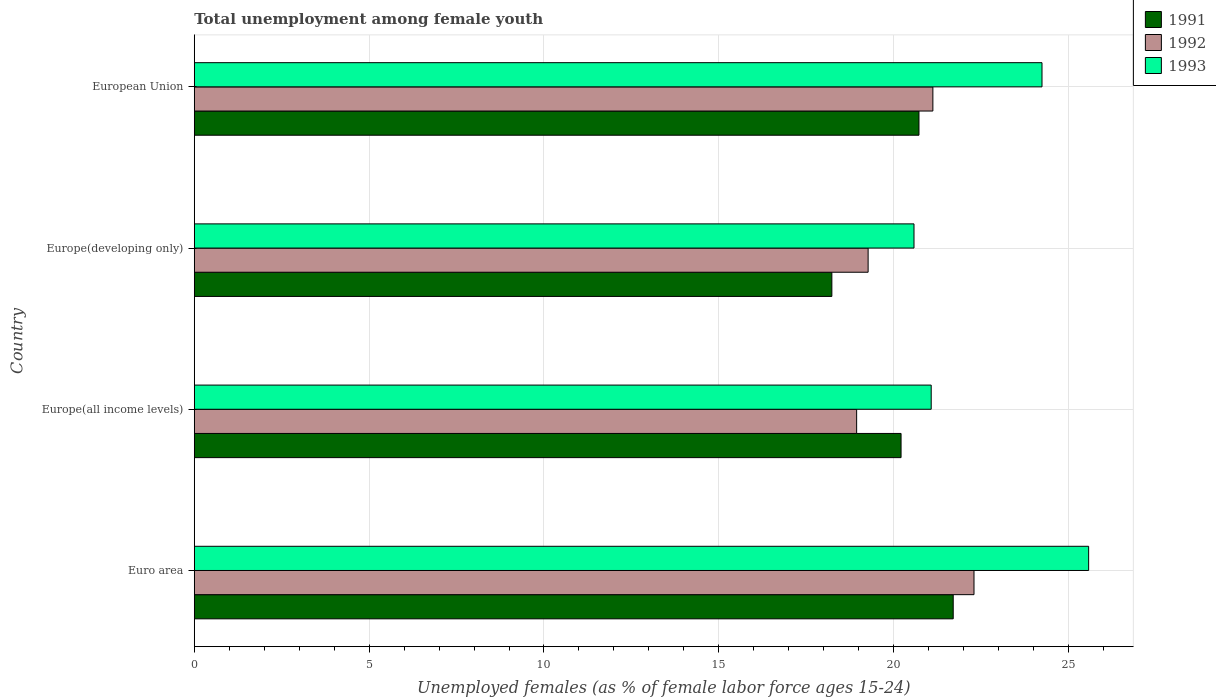How many different coloured bars are there?
Provide a short and direct response. 3. How many groups of bars are there?
Give a very brief answer. 4. How many bars are there on the 3rd tick from the top?
Ensure brevity in your answer.  3. How many bars are there on the 3rd tick from the bottom?
Give a very brief answer. 3. What is the label of the 3rd group of bars from the top?
Provide a succinct answer. Europe(all income levels). What is the percentage of unemployed females in in 1993 in Europe(all income levels)?
Ensure brevity in your answer.  21.07. Across all countries, what is the maximum percentage of unemployed females in in 1993?
Ensure brevity in your answer.  25.57. Across all countries, what is the minimum percentage of unemployed females in in 1993?
Your answer should be very brief. 20.58. In which country was the percentage of unemployed females in in 1991 minimum?
Make the answer very short. Europe(developing only). What is the total percentage of unemployed females in in 1993 in the graph?
Give a very brief answer. 91.47. What is the difference between the percentage of unemployed females in in 1991 in Europe(all income levels) and that in Europe(developing only)?
Provide a succinct answer. 1.98. What is the difference between the percentage of unemployed females in in 1991 in Europe(all income levels) and the percentage of unemployed females in in 1992 in Europe(developing only)?
Ensure brevity in your answer.  0.94. What is the average percentage of unemployed females in in 1993 per country?
Offer a very short reply. 22.87. What is the difference between the percentage of unemployed females in in 1993 and percentage of unemployed females in in 1992 in European Union?
Keep it short and to the point. 3.12. In how many countries, is the percentage of unemployed females in in 1992 greater than 4 %?
Make the answer very short. 4. What is the ratio of the percentage of unemployed females in in 1992 in Euro area to that in European Union?
Offer a terse response. 1.06. Is the percentage of unemployed females in in 1992 in Europe(all income levels) less than that in Europe(developing only)?
Offer a very short reply. Yes. Is the difference between the percentage of unemployed females in in 1993 in Euro area and Europe(developing only) greater than the difference between the percentage of unemployed females in in 1992 in Euro area and Europe(developing only)?
Give a very brief answer. Yes. What is the difference between the highest and the second highest percentage of unemployed females in in 1991?
Provide a short and direct response. 0.98. What is the difference between the highest and the lowest percentage of unemployed females in in 1991?
Your response must be concise. 3.47. Is the sum of the percentage of unemployed females in in 1992 in Europe(all income levels) and Europe(developing only) greater than the maximum percentage of unemployed females in in 1993 across all countries?
Make the answer very short. Yes. Is it the case that in every country, the sum of the percentage of unemployed females in in 1993 and percentage of unemployed females in in 1992 is greater than the percentage of unemployed females in in 1991?
Keep it short and to the point. Yes. What is the difference between two consecutive major ticks on the X-axis?
Keep it short and to the point. 5. Are the values on the major ticks of X-axis written in scientific E-notation?
Your answer should be very brief. No. Does the graph contain any zero values?
Make the answer very short. No. Does the graph contain grids?
Give a very brief answer. Yes. Where does the legend appear in the graph?
Your answer should be very brief. Top right. What is the title of the graph?
Ensure brevity in your answer.  Total unemployment among female youth. What is the label or title of the X-axis?
Offer a very short reply. Unemployed females (as % of female labor force ages 15-24). What is the label or title of the Y-axis?
Your response must be concise. Country. What is the Unemployed females (as % of female labor force ages 15-24) in 1991 in Euro area?
Give a very brief answer. 21.7. What is the Unemployed females (as % of female labor force ages 15-24) in 1992 in Euro area?
Your answer should be compact. 22.3. What is the Unemployed females (as % of female labor force ages 15-24) of 1993 in Euro area?
Your response must be concise. 25.57. What is the Unemployed females (as % of female labor force ages 15-24) in 1991 in Europe(all income levels)?
Offer a terse response. 20.21. What is the Unemployed females (as % of female labor force ages 15-24) in 1992 in Europe(all income levels)?
Provide a short and direct response. 18.94. What is the Unemployed females (as % of female labor force ages 15-24) in 1993 in Europe(all income levels)?
Give a very brief answer. 21.07. What is the Unemployed females (as % of female labor force ages 15-24) in 1991 in Europe(developing only)?
Give a very brief answer. 18.23. What is the Unemployed females (as % of female labor force ages 15-24) of 1992 in Europe(developing only)?
Your response must be concise. 19.27. What is the Unemployed females (as % of female labor force ages 15-24) of 1993 in Europe(developing only)?
Provide a short and direct response. 20.58. What is the Unemployed females (as % of female labor force ages 15-24) of 1991 in European Union?
Provide a succinct answer. 20.72. What is the Unemployed females (as % of female labor force ages 15-24) in 1992 in European Union?
Provide a succinct answer. 21.12. What is the Unemployed females (as % of female labor force ages 15-24) of 1993 in European Union?
Your answer should be very brief. 24.24. Across all countries, what is the maximum Unemployed females (as % of female labor force ages 15-24) in 1991?
Give a very brief answer. 21.7. Across all countries, what is the maximum Unemployed females (as % of female labor force ages 15-24) of 1992?
Keep it short and to the point. 22.3. Across all countries, what is the maximum Unemployed females (as % of female labor force ages 15-24) in 1993?
Provide a succinct answer. 25.57. Across all countries, what is the minimum Unemployed females (as % of female labor force ages 15-24) in 1991?
Make the answer very short. 18.23. Across all countries, what is the minimum Unemployed females (as % of female labor force ages 15-24) in 1992?
Your answer should be compact. 18.94. Across all countries, what is the minimum Unemployed females (as % of female labor force ages 15-24) of 1993?
Offer a terse response. 20.58. What is the total Unemployed females (as % of female labor force ages 15-24) of 1991 in the graph?
Offer a very short reply. 80.87. What is the total Unemployed females (as % of female labor force ages 15-24) in 1992 in the graph?
Give a very brief answer. 81.63. What is the total Unemployed females (as % of female labor force ages 15-24) in 1993 in the graph?
Offer a terse response. 91.47. What is the difference between the Unemployed females (as % of female labor force ages 15-24) in 1991 in Euro area and that in Europe(all income levels)?
Your answer should be compact. 1.49. What is the difference between the Unemployed females (as % of female labor force ages 15-24) of 1992 in Euro area and that in Europe(all income levels)?
Your response must be concise. 3.36. What is the difference between the Unemployed females (as % of female labor force ages 15-24) of 1993 in Euro area and that in Europe(all income levels)?
Offer a very short reply. 4.5. What is the difference between the Unemployed females (as % of female labor force ages 15-24) in 1991 in Euro area and that in Europe(developing only)?
Your answer should be very brief. 3.47. What is the difference between the Unemployed females (as % of female labor force ages 15-24) of 1992 in Euro area and that in Europe(developing only)?
Offer a terse response. 3.03. What is the difference between the Unemployed females (as % of female labor force ages 15-24) in 1993 in Euro area and that in Europe(developing only)?
Your answer should be compact. 4.99. What is the difference between the Unemployed females (as % of female labor force ages 15-24) of 1991 in Euro area and that in European Union?
Offer a terse response. 0.98. What is the difference between the Unemployed females (as % of female labor force ages 15-24) in 1992 in Euro area and that in European Union?
Keep it short and to the point. 1.18. What is the difference between the Unemployed females (as % of female labor force ages 15-24) in 1993 in Euro area and that in European Union?
Your answer should be very brief. 1.33. What is the difference between the Unemployed females (as % of female labor force ages 15-24) of 1991 in Europe(all income levels) and that in Europe(developing only)?
Provide a short and direct response. 1.98. What is the difference between the Unemployed females (as % of female labor force ages 15-24) of 1992 in Europe(all income levels) and that in Europe(developing only)?
Ensure brevity in your answer.  -0.33. What is the difference between the Unemployed females (as % of female labor force ages 15-24) of 1993 in Europe(all income levels) and that in Europe(developing only)?
Your answer should be very brief. 0.49. What is the difference between the Unemployed females (as % of female labor force ages 15-24) in 1991 in Europe(all income levels) and that in European Union?
Your response must be concise. -0.51. What is the difference between the Unemployed females (as % of female labor force ages 15-24) in 1992 in Europe(all income levels) and that in European Union?
Your response must be concise. -2.18. What is the difference between the Unemployed females (as % of female labor force ages 15-24) of 1993 in Europe(all income levels) and that in European Union?
Keep it short and to the point. -3.17. What is the difference between the Unemployed females (as % of female labor force ages 15-24) in 1991 in Europe(developing only) and that in European Union?
Give a very brief answer. -2.49. What is the difference between the Unemployed females (as % of female labor force ages 15-24) in 1992 in Europe(developing only) and that in European Union?
Provide a short and direct response. -1.85. What is the difference between the Unemployed females (as % of female labor force ages 15-24) in 1993 in Europe(developing only) and that in European Union?
Provide a short and direct response. -3.66. What is the difference between the Unemployed females (as % of female labor force ages 15-24) in 1991 in Euro area and the Unemployed females (as % of female labor force ages 15-24) in 1992 in Europe(all income levels)?
Ensure brevity in your answer.  2.76. What is the difference between the Unemployed females (as % of female labor force ages 15-24) in 1991 in Euro area and the Unemployed females (as % of female labor force ages 15-24) in 1993 in Europe(all income levels)?
Your answer should be compact. 0.63. What is the difference between the Unemployed females (as % of female labor force ages 15-24) of 1992 in Euro area and the Unemployed females (as % of female labor force ages 15-24) of 1993 in Europe(all income levels)?
Your answer should be compact. 1.22. What is the difference between the Unemployed females (as % of female labor force ages 15-24) of 1991 in Euro area and the Unemployed females (as % of female labor force ages 15-24) of 1992 in Europe(developing only)?
Keep it short and to the point. 2.43. What is the difference between the Unemployed females (as % of female labor force ages 15-24) in 1991 in Euro area and the Unemployed females (as % of female labor force ages 15-24) in 1993 in Europe(developing only)?
Your answer should be very brief. 1.12. What is the difference between the Unemployed females (as % of female labor force ages 15-24) of 1992 in Euro area and the Unemployed females (as % of female labor force ages 15-24) of 1993 in Europe(developing only)?
Make the answer very short. 1.72. What is the difference between the Unemployed females (as % of female labor force ages 15-24) of 1991 in Euro area and the Unemployed females (as % of female labor force ages 15-24) of 1992 in European Union?
Your response must be concise. 0.58. What is the difference between the Unemployed females (as % of female labor force ages 15-24) in 1991 in Euro area and the Unemployed females (as % of female labor force ages 15-24) in 1993 in European Union?
Provide a short and direct response. -2.54. What is the difference between the Unemployed females (as % of female labor force ages 15-24) of 1992 in Euro area and the Unemployed females (as % of female labor force ages 15-24) of 1993 in European Union?
Make the answer very short. -1.94. What is the difference between the Unemployed females (as % of female labor force ages 15-24) in 1991 in Europe(all income levels) and the Unemployed females (as % of female labor force ages 15-24) in 1992 in Europe(developing only)?
Offer a very short reply. 0.94. What is the difference between the Unemployed females (as % of female labor force ages 15-24) in 1991 in Europe(all income levels) and the Unemployed females (as % of female labor force ages 15-24) in 1993 in Europe(developing only)?
Keep it short and to the point. -0.37. What is the difference between the Unemployed females (as % of female labor force ages 15-24) in 1992 in Europe(all income levels) and the Unemployed females (as % of female labor force ages 15-24) in 1993 in Europe(developing only)?
Offer a very short reply. -1.64. What is the difference between the Unemployed females (as % of female labor force ages 15-24) of 1991 in Europe(all income levels) and the Unemployed females (as % of female labor force ages 15-24) of 1992 in European Union?
Offer a terse response. -0.91. What is the difference between the Unemployed females (as % of female labor force ages 15-24) of 1991 in Europe(all income levels) and the Unemployed females (as % of female labor force ages 15-24) of 1993 in European Union?
Your answer should be compact. -4.03. What is the difference between the Unemployed females (as % of female labor force ages 15-24) of 1992 in Europe(all income levels) and the Unemployed females (as % of female labor force ages 15-24) of 1993 in European Union?
Provide a succinct answer. -5.3. What is the difference between the Unemployed females (as % of female labor force ages 15-24) in 1991 in Europe(developing only) and the Unemployed females (as % of female labor force ages 15-24) in 1992 in European Union?
Give a very brief answer. -2.89. What is the difference between the Unemployed females (as % of female labor force ages 15-24) of 1991 in Europe(developing only) and the Unemployed females (as % of female labor force ages 15-24) of 1993 in European Union?
Your answer should be very brief. -6.01. What is the difference between the Unemployed females (as % of female labor force ages 15-24) in 1992 in Europe(developing only) and the Unemployed females (as % of female labor force ages 15-24) in 1993 in European Union?
Offer a terse response. -4.97. What is the average Unemployed females (as % of female labor force ages 15-24) of 1991 per country?
Give a very brief answer. 20.22. What is the average Unemployed females (as % of female labor force ages 15-24) in 1992 per country?
Offer a very short reply. 20.41. What is the average Unemployed females (as % of female labor force ages 15-24) of 1993 per country?
Provide a succinct answer. 22.87. What is the difference between the Unemployed females (as % of female labor force ages 15-24) in 1991 and Unemployed females (as % of female labor force ages 15-24) in 1992 in Euro area?
Your answer should be very brief. -0.59. What is the difference between the Unemployed females (as % of female labor force ages 15-24) in 1991 and Unemployed females (as % of female labor force ages 15-24) in 1993 in Euro area?
Ensure brevity in your answer.  -3.87. What is the difference between the Unemployed females (as % of female labor force ages 15-24) in 1992 and Unemployed females (as % of female labor force ages 15-24) in 1993 in Euro area?
Provide a succinct answer. -3.28. What is the difference between the Unemployed females (as % of female labor force ages 15-24) of 1991 and Unemployed females (as % of female labor force ages 15-24) of 1992 in Europe(all income levels)?
Make the answer very short. 1.27. What is the difference between the Unemployed females (as % of female labor force ages 15-24) in 1991 and Unemployed females (as % of female labor force ages 15-24) in 1993 in Europe(all income levels)?
Your answer should be compact. -0.86. What is the difference between the Unemployed females (as % of female labor force ages 15-24) of 1992 and Unemployed females (as % of female labor force ages 15-24) of 1993 in Europe(all income levels)?
Offer a very short reply. -2.13. What is the difference between the Unemployed females (as % of female labor force ages 15-24) in 1991 and Unemployed females (as % of female labor force ages 15-24) in 1992 in Europe(developing only)?
Provide a succinct answer. -1.04. What is the difference between the Unemployed females (as % of female labor force ages 15-24) of 1991 and Unemployed females (as % of female labor force ages 15-24) of 1993 in Europe(developing only)?
Make the answer very short. -2.35. What is the difference between the Unemployed females (as % of female labor force ages 15-24) in 1992 and Unemployed females (as % of female labor force ages 15-24) in 1993 in Europe(developing only)?
Offer a terse response. -1.31. What is the difference between the Unemployed females (as % of female labor force ages 15-24) in 1991 and Unemployed females (as % of female labor force ages 15-24) in 1992 in European Union?
Provide a succinct answer. -0.4. What is the difference between the Unemployed females (as % of female labor force ages 15-24) of 1991 and Unemployed females (as % of female labor force ages 15-24) of 1993 in European Union?
Make the answer very short. -3.52. What is the difference between the Unemployed females (as % of female labor force ages 15-24) of 1992 and Unemployed females (as % of female labor force ages 15-24) of 1993 in European Union?
Keep it short and to the point. -3.12. What is the ratio of the Unemployed females (as % of female labor force ages 15-24) in 1991 in Euro area to that in Europe(all income levels)?
Your response must be concise. 1.07. What is the ratio of the Unemployed females (as % of female labor force ages 15-24) of 1992 in Euro area to that in Europe(all income levels)?
Your answer should be compact. 1.18. What is the ratio of the Unemployed females (as % of female labor force ages 15-24) of 1993 in Euro area to that in Europe(all income levels)?
Offer a terse response. 1.21. What is the ratio of the Unemployed females (as % of female labor force ages 15-24) of 1991 in Euro area to that in Europe(developing only)?
Make the answer very short. 1.19. What is the ratio of the Unemployed females (as % of female labor force ages 15-24) of 1992 in Euro area to that in Europe(developing only)?
Keep it short and to the point. 1.16. What is the ratio of the Unemployed females (as % of female labor force ages 15-24) of 1993 in Euro area to that in Europe(developing only)?
Make the answer very short. 1.24. What is the ratio of the Unemployed females (as % of female labor force ages 15-24) in 1991 in Euro area to that in European Union?
Offer a terse response. 1.05. What is the ratio of the Unemployed females (as % of female labor force ages 15-24) in 1992 in Euro area to that in European Union?
Give a very brief answer. 1.06. What is the ratio of the Unemployed females (as % of female labor force ages 15-24) of 1993 in Euro area to that in European Union?
Your answer should be compact. 1.05. What is the ratio of the Unemployed females (as % of female labor force ages 15-24) in 1991 in Europe(all income levels) to that in Europe(developing only)?
Offer a very short reply. 1.11. What is the ratio of the Unemployed females (as % of female labor force ages 15-24) of 1993 in Europe(all income levels) to that in Europe(developing only)?
Ensure brevity in your answer.  1.02. What is the ratio of the Unemployed females (as % of female labor force ages 15-24) of 1991 in Europe(all income levels) to that in European Union?
Give a very brief answer. 0.98. What is the ratio of the Unemployed females (as % of female labor force ages 15-24) of 1992 in Europe(all income levels) to that in European Union?
Keep it short and to the point. 0.9. What is the ratio of the Unemployed females (as % of female labor force ages 15-24) of 1993 in Europe(all income levels) to that in European Union?
Your answer should be very brief. 0.87. What is the ratio of the Unemployed females (as % of female labor force ages 15-24) in 1991 in Europe(developing only) to that in European Union?
Provide a succinct answer. 0.88. What is the ratio of the Unemployed females (as % of female labor force ages 15-24) of 1992 in Europe(developing only) to that in European Union?
Your answer should be very brief. 0.91. What is the ratio of the Unemployed females (as % of female labor force ages 15-24) in 1993 in Europe(developing only) to that in European Union?
Offer a very short reply. 0.85. What is the difference between the highest and the second highest Unemployed females (as % of female labor force ages 15-24) of 1991?
Keep it short and to the point. 0.98. What is the difference between the highest and the second highest Unemployed females (as % of female labor force ages 15-24) in 1992?
Keep it short and to the point. 1.18. What is the difference between the highest and the second highest Unemployed females (as % of female labor force ages 15-24) of 1993?
Your answer should be very brief. 1.33. What is the difference between the highest and the lowest Unemployed females (as % of female labor force ages 15-24) in 1991?
Provide a short and direct response. 3.47. What is the difference between the highest and the lowest Unemployed females (as % of female labor force ages 15-24) in 1992?
Your response must be concise. 3.36. What is the difference between the highest and the lowest Unemployed females (as % of female labor force ages 15-24) in 1993?
Your response must be concise. 4.99. 